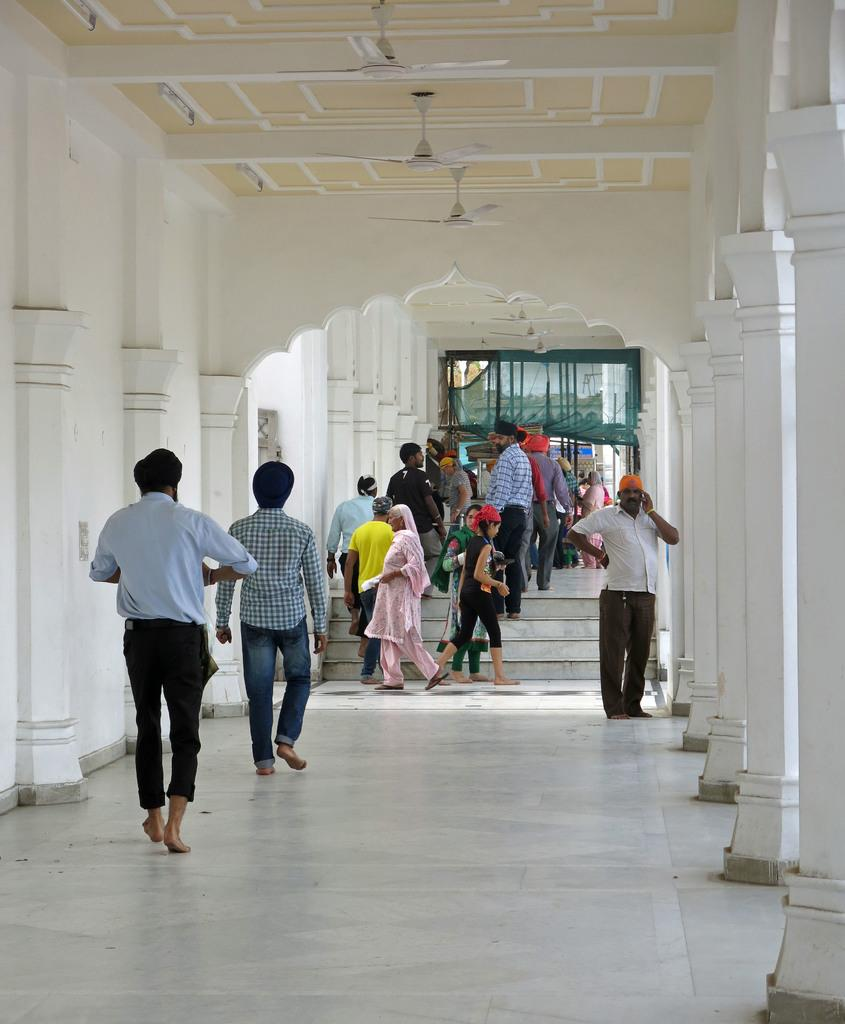Who or what can be seen in the image? There are people in the image. What part of the image can be seen beneath the people? The floor is visible in the image. Are there any architectural features in the people might use to move between different levels? Yes, there are steps in the image. What type of support structures are present in the image? There are pillars in the image. What is present on the ceiling in the image? Fans are present on the ceiling. What type of coil can be seen in the image? There is no coil present in the image. How many pages are visible in the image? There are no pages present in the image. 